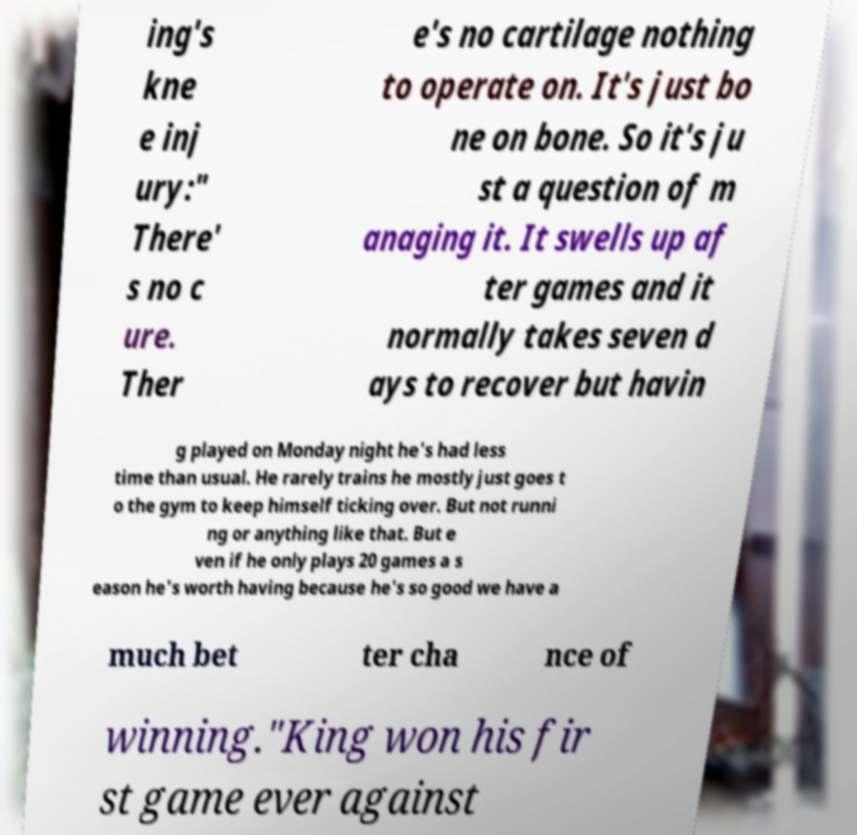Can you accurately transcribe the text from the provided image for me? ing's kne e inj ury:" There' s no c ure. Ther e's no cartilage nothing to operate on. It's just bo ne on bone. So it's ju st a question of m anaging it. It swells up af ter games and it normally takes seven d ays to recover but havin g played on Monday night he's had less time than usual. He rarely trains he mostly just goes t o the gym to keep himself ticking over. But not runni ng or anything like that. But e ven if he only plays 20 games a s eason he's worth having because he's so good we have a much bet ter cha nce of winning."King won his fir st game ever against 